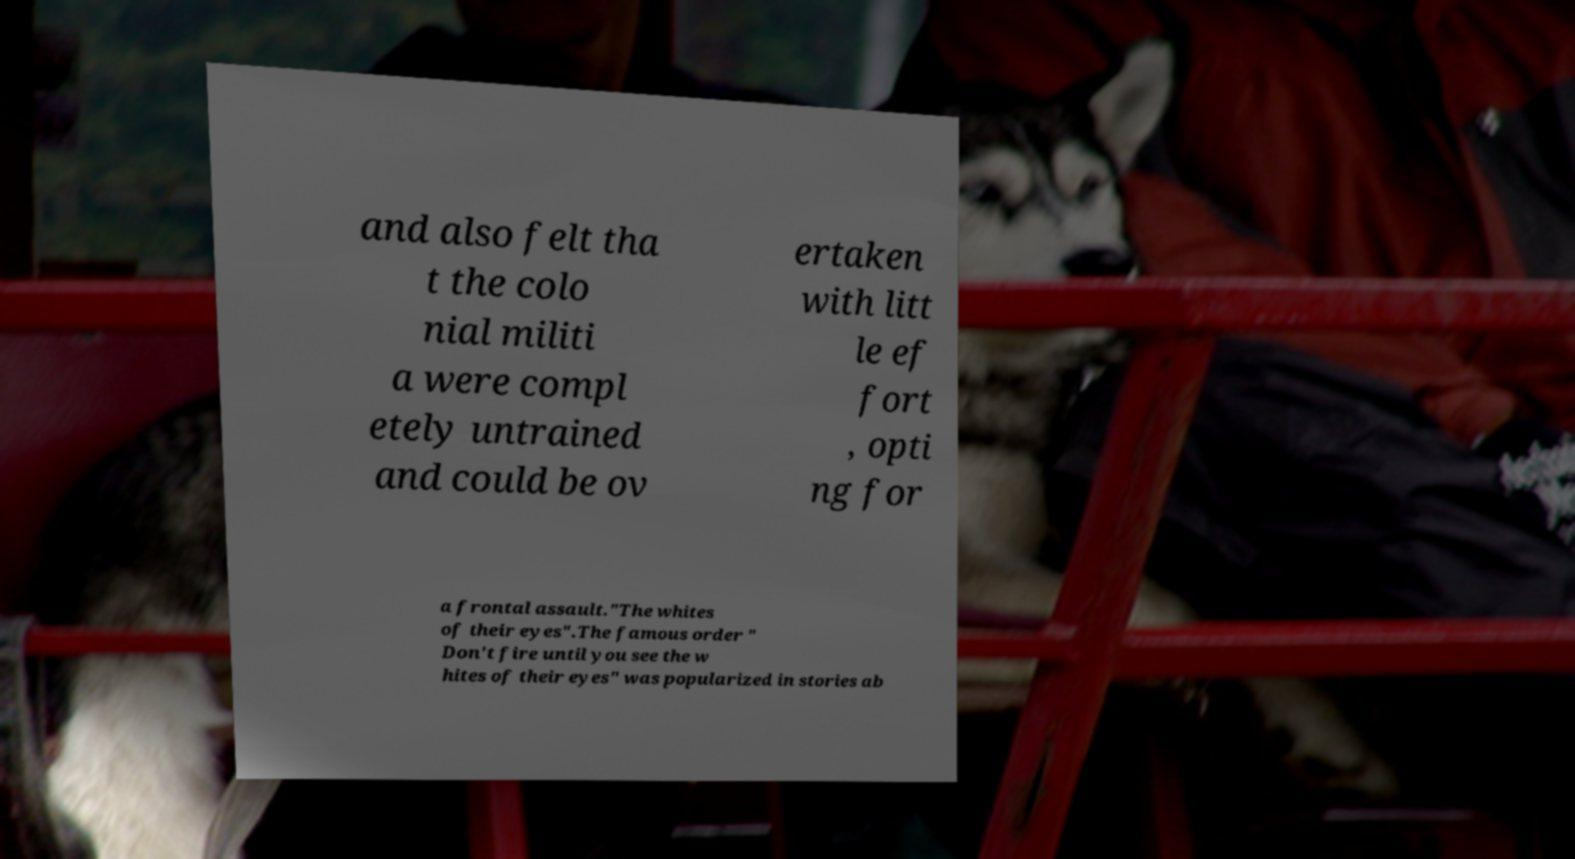For documentation purposes, I need the text within this image transcribed. Could you provide that? and also felt tha t the colo nial militi a were compl etely untrained and could be ov ertaken with litt le ef fort , opti ng for a frontal assault."The whites of their eyes".The famous order " Don't fire until you see the w hites of their eyes" was popularized in stories ab 